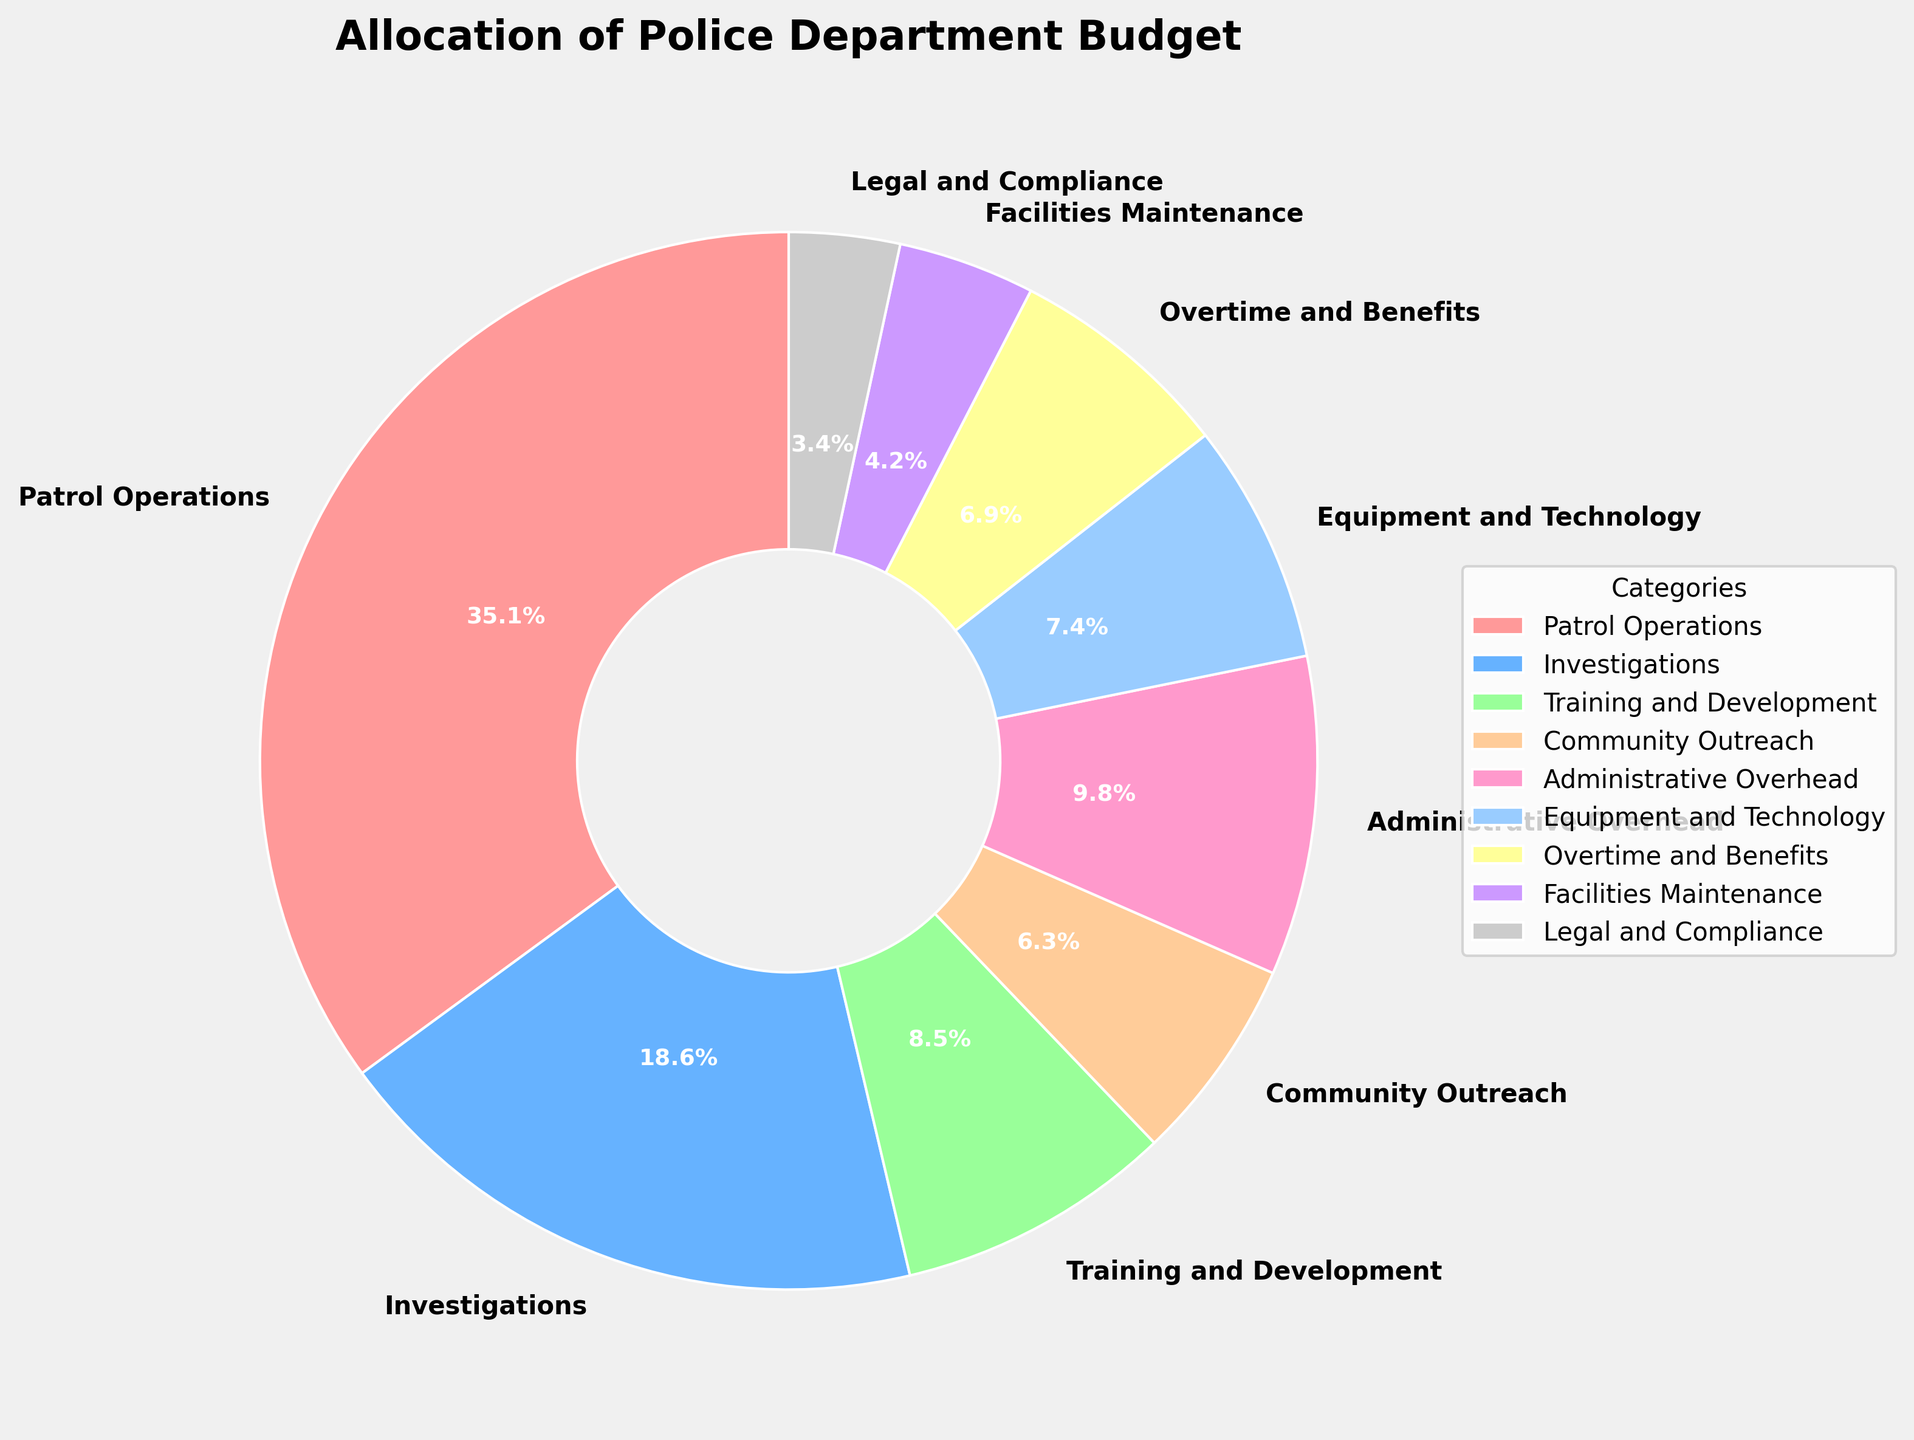What is the category with the highest allocation? According to the pie chart, "Patrol Operations" has the largest slice of the pie, making it the highest allocation category.
Answer: Patrol Operations What is the total percentage allocated to categories related to personnel (Patrol Operations, Investigations, Training and Development, and Overtime and Benefits)? Sum the percentages of the mentioned categories: 35.2 (Patrol Operations) + 18.7 (Investigations) + 8.5 (Training and Development) + 6.9 (Overtime and Benefits) = 69.3%.
Answer: 69.3% Which category has the smallest allocation, and what is its percentage? The pie chart shows that "Legal and Compliance" has the smallest slice, making it the category with the smallest allocation at 3.4%.
Answer: Legal and Compliance, 3.4% Compare the allocation to Community Outreach and Administrative Overhead. Which one is higher and by how much? Administrative Overhead is higher. Subtract the percentage of Community Outreach from Administrative Overhead: 9.8 (Administrative Overhead) - 6.3 (Community Outreach) = 3.5%.
Answer: Administrative Overhead by 3.5% What is the combined percentage of Equipment and Technology and Facilities Maintenance? Sum the percentages of the categories: 7.4 (Equipment and Technology) + 4.2 (Facilities Maintenance) = 11.6%.
Answer: 11.6% What's the difference in allocation between Training and Development and Legal and Compliance? Subtract the percentage of Legal and Compliance from Training and Development: 8.5 (Training and Development) - 3.4 (Legal and Compliance) = 5.1%.
Answer: 5.1% Which category is represented by the blue slice in the pie chart? The blue slice, being one of the color-coded sections, represents "Investigations."
Answer: Investigations If the allocation for Patrol Operations increased by 5%, what would the new percentage be? Add 5% to the current percentage of Patrol Operations: 35.2 + 5 = 40.2%.
Answer: 40.2% Determine the average allocation percentage for all categories. Sum all percentages and divide by the number of categories: (35.2 + 18.7 + 8.5 + 6.3 + 9.8 + 7.4 + 6.9 + 4.2 + 3.4) / 9 = 100.4 / 9 ≈ 11.16%.
Answer: ≈ 11.16% Which allocation percentage is closest to the average allocation percentage for all categories? The average allocation is approximately 11.16%. Compare each to find the closest: 9.8% (Administrative Overhead) is the closest.
Answer: Administrative Overhead 